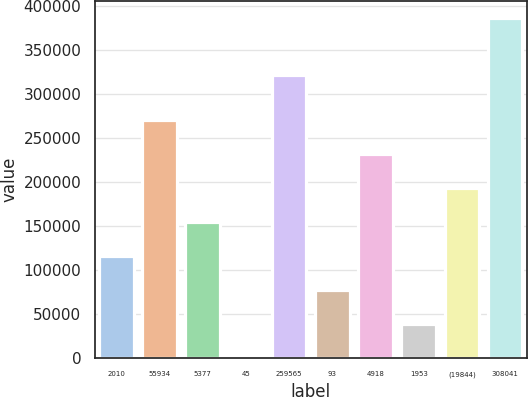Convert chart to OTSL. <chart><loc_0><loc_0><loc_500><loc_500><bar_chart><fcel>2010<fcel>55934<fcel>5377<fcel>45<fcel>259565<fcel>93<fcel>4918<fcel>1953<fcel>(19844)<fcel>308041<nl><fcel>116095<fcel>270687<fcel>154743<fcel>151<fcel>322393<fcel>77447<fcel>232039<fcel>38799<fcel>193391<fcel>386631<nl></chart> 